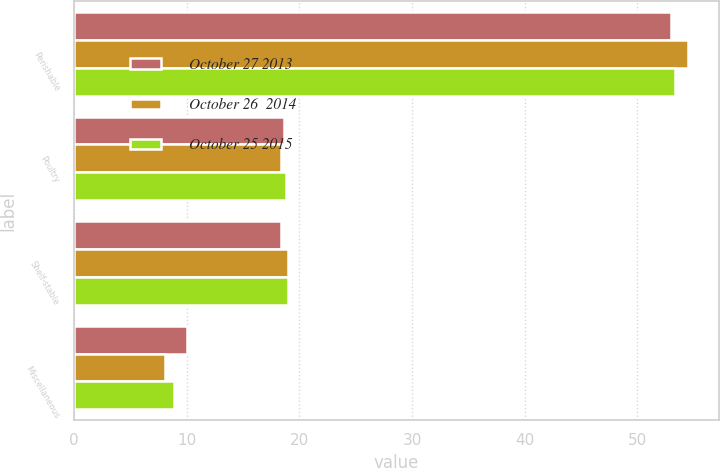Convert chart. <chart><loc_0><loc_0><loc_500><loc_500><stacked_bar_chart><ecel><fcel>Perishable<fcel>Poultry<fcel>Shelf-stable<fcel>Miscellaneous<nl><fcel>October 27 2013<fcel>53<fcel>18.6<fcel>18.4<fcel>10<nl><fcel>October 26  2014<fcel>54.5<fcel>18.4<fcel>19<fcel>8.1<nl><fcel>October 25 2015<fcel>53.3<fcel>18.8<fcel>19<fcel>8.9<nl></chart> 